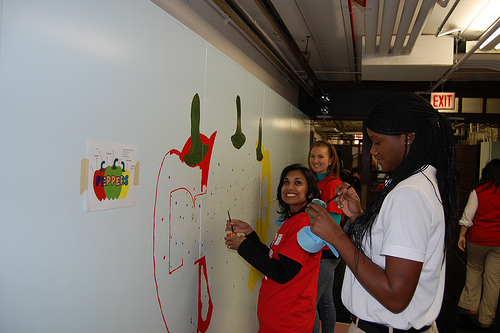<image>
Is the sign behind the woman? Yes. From this viewpoint, the sign is positioned behind the woman, with the woman partially or fully occluding the sign. Is there a girl next to the wall? Yes. The girl is positioned adjacent to the wall, located nearby in the same general area. 